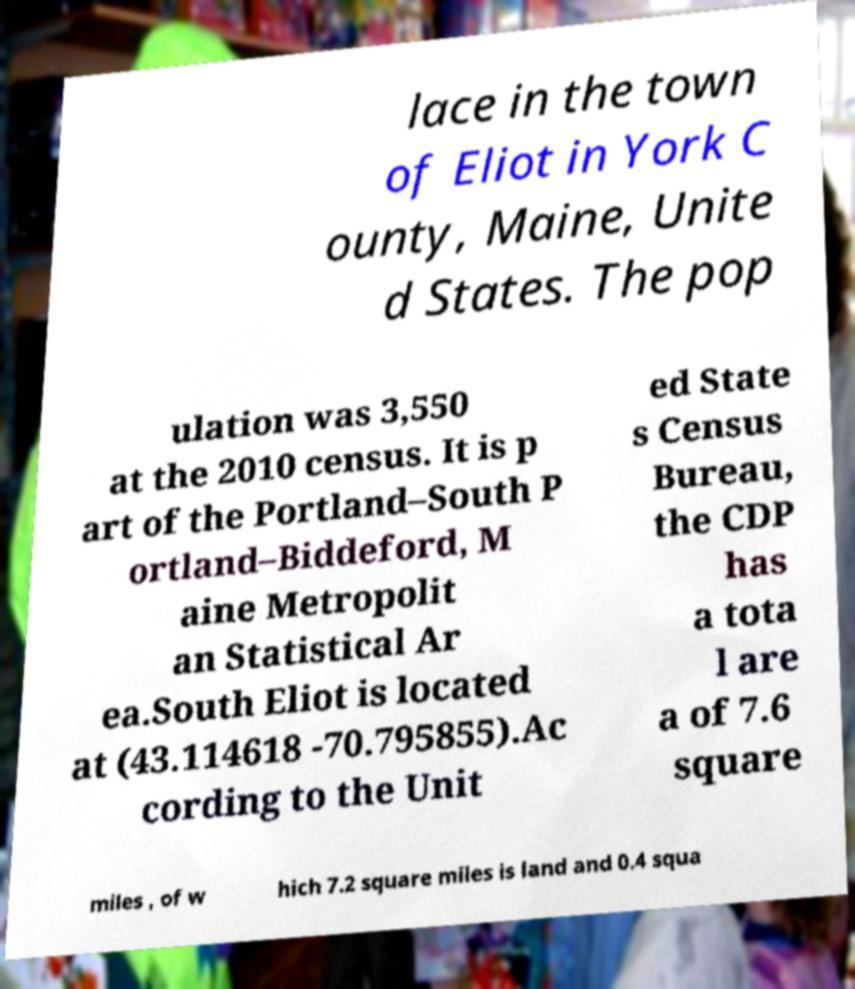Can you read and provide the text displayed in the image?This photo seems to have some interesting text. Can you extract and type it out for me? lace in the town of Eliot in York C ounty, Maine, Unite d States. The pop ulation was 3,550 at the 2010 census. It is p art of the Portland–South P ortland–Biddeford, M aine Metropolit an Statistical Ar ea.South Eliot is located at (43.114618 -70.795855).Ac cording to the Unit ed State s Census Bureau, the CDP has a tota l are a of 7.6 square miles , of w hich 7.2 square miles is land and 0.4 squa 